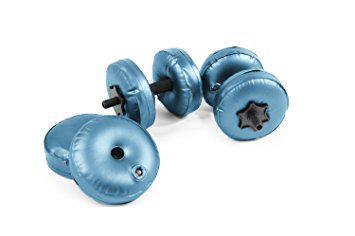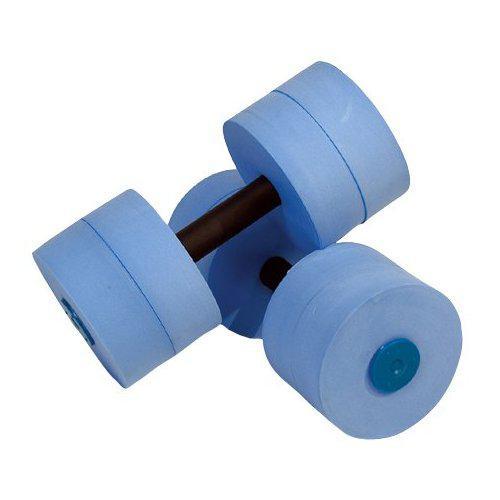The first image is the image on the left, the second image is the image on the right. Given the left and right images, does the statement "There are four blue water dumbbell with only two that have white stripes on it." hold true? Answer yes or no. No. 